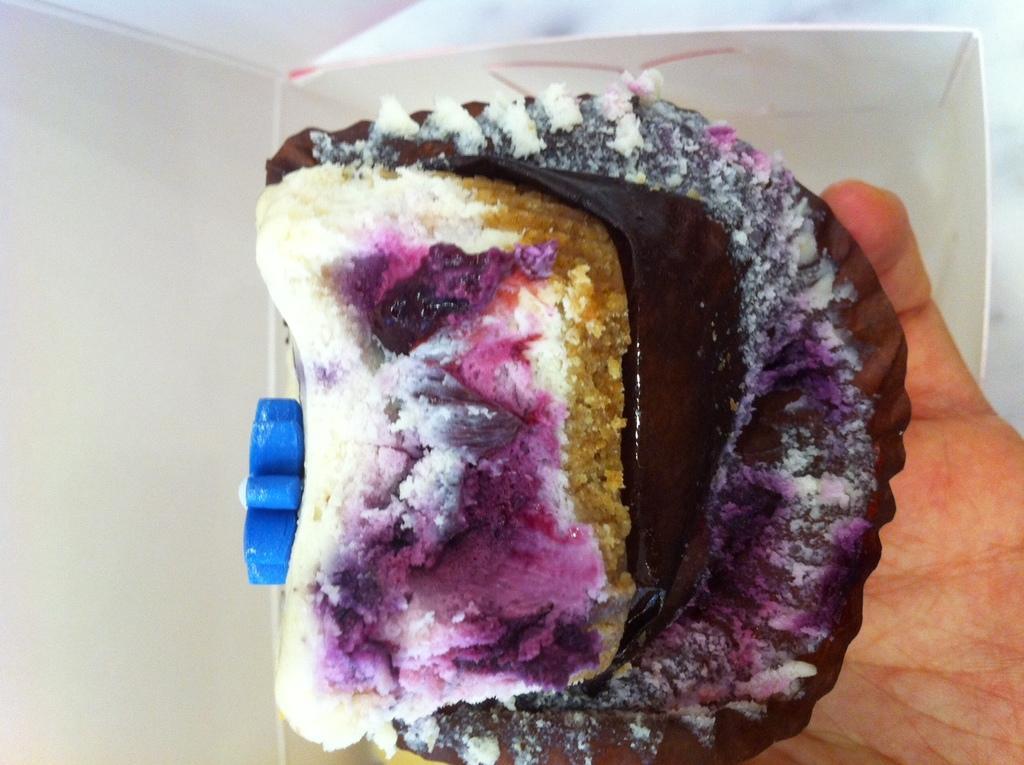Please provide a concise description of this image. In the picture we can a person's hand is holding the food item and behind it, we can see the white box. 